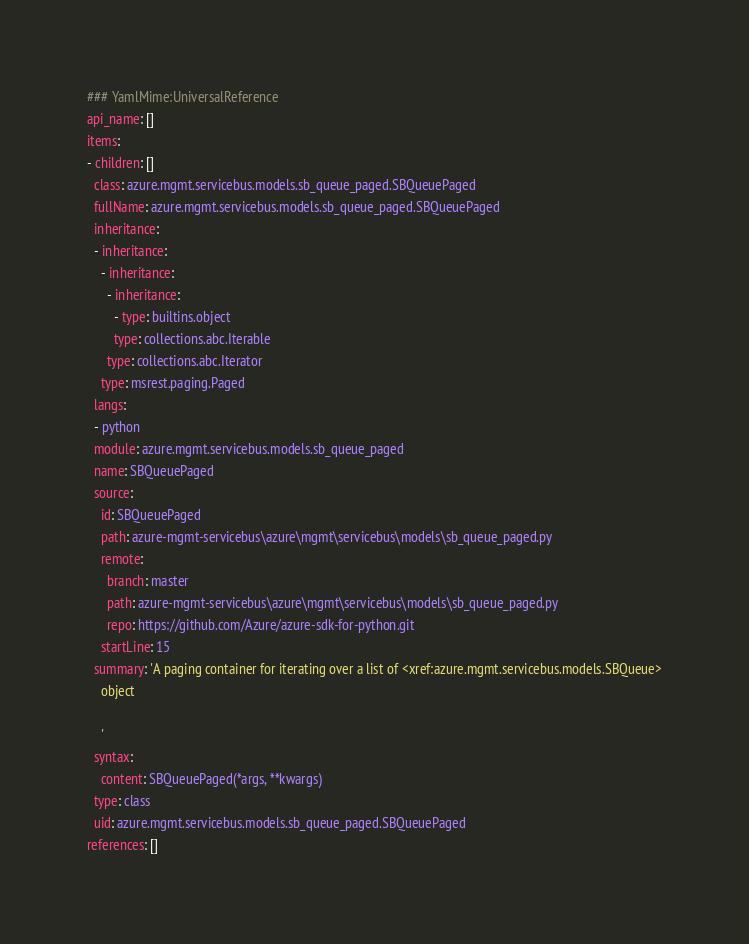<code> <loc_0><loc_0><loc_500><loc_500><_YAML_>### YamlMime:UniversalReference
api_name: []
items:
- children: []
  class: azure.mgmt.servicebus.models.sb_queue_paged.SBQueuePaged
  fullName: azure.mgmt.servicebus.models.sb_queue_paged.SBQueuePaged
  inheritance:
  - inheritance:
    - inheritance:
      - inheritance:
        - type: builtins.object
        type: collections.abc.Iterable
      type: collections.abc.Iterator
    type: msrest.paging.Paged
  langs:
  - python
  module: azure.mgmt.servicebus.models.sb_queue_paged
  name: SBQueuePaged
  source:
    id: SBQueuePaged
    path: azure-mgmt-servicebus\azure\mgmt\servicebus\models\sb_queue_paged.py
    remote:
      branch: master
      path: azure-mgmt-servicebus\azure\mgmt\servicebus\models\sb_queue_paged.py
      repo: https://github.com/Azure/azure-sdk-for-python.git
    startLine: 15
  summary: 'A paging container for iterating over a list of <xref:azure.mgmt.servicebus.models.SBQueue>
    object

    '
  syntax:
    content: SBQueuePaged(*args, **kwargs)
  type: class
  uid: azure.mgmt.servicebus.models.sb_queue_paged.SBQueuePaged
references: []
</code> 